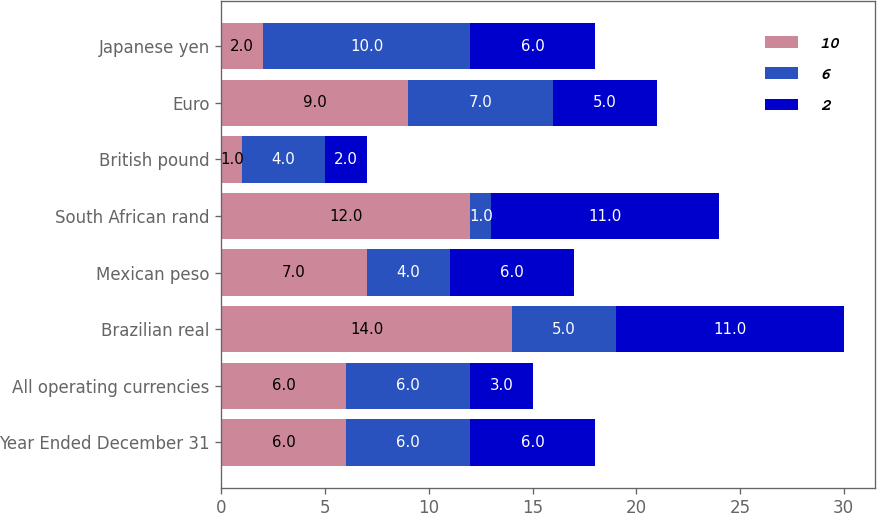Convert chart to OTSL. <chart><loc_0><loc_0><loc_500><loc_500><stacked_bar_chart><ecel><fcel>Year Ended December 31<fcel>All operating currencies<fcel>Brazilian real<fcel>Mexican peso<fcel>South African rand<fcel>British pound<fcel>Euro<fcel>Japanese yen<nl><fcel>10<fcel>6<fcel>6<fcel>14<fcel>7<fcel>12<fcel>1<fcel>9<fcel>2<nl><fcel>6<fcel>6<fcel>6<fcel>5<fcel>4<fcel>1<fcel>4<fcel>7<fcel>10<nl><fcel>2<fcel>6<fcel>3<fcel>11<fcel>6<fcel>11<fcel>2<fcel>5<fcel>6<nl></chart> 